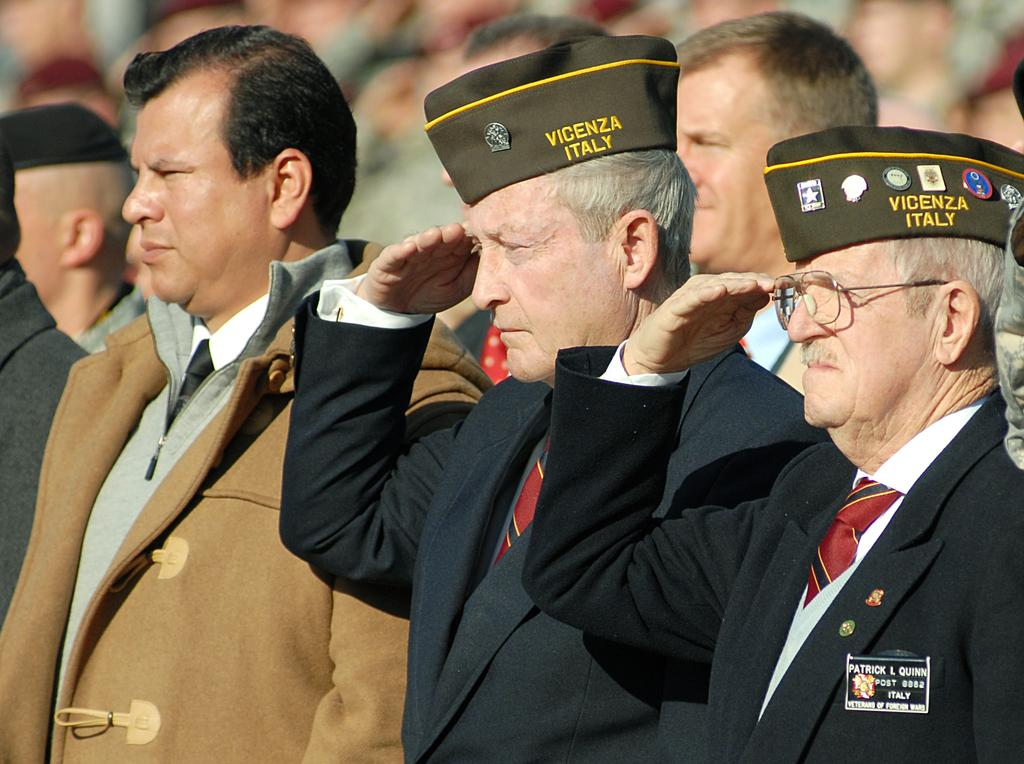What is happening in the image involving the people? Two people are saluting in the image. What else can be seen in the image besides the people? Wire caps are visible in the image. Can you describe the background of the image? The background of the image is blurry. What type of wool is being used to create the minute in the image? There is no minute or wool present in the image. 